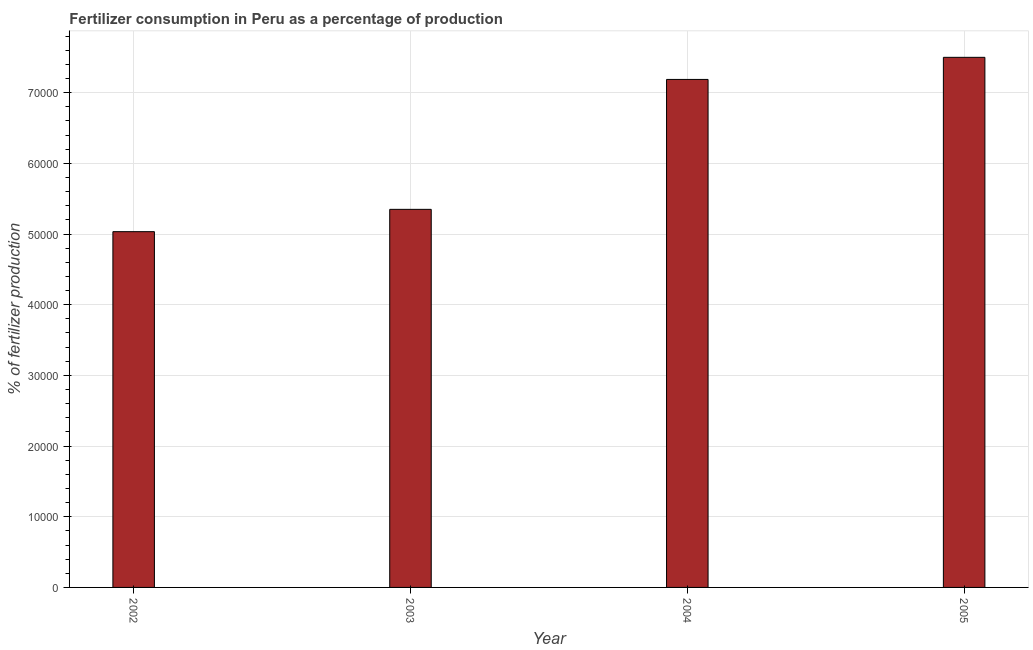Does the graph contain any zero values?
Provide a succinct answer. No. Does the graph contain grids?
Provide a short and direct response. Yes. What is the title of the graph?
Offer a very short reply. Fertilizer consumption in Peru as a percentage of production. What is the label or title of the X-axis?
Keep it short and to the point. Year. What is the label or title of the Y-axis?
Keep it short and to the point. % of fertilizer production. What is the amount of fertilizer consumption in 2005?
Give a very brief answer. 7.50e+04. Across all years, what is the maximum amount of fertilizer consumption?
Offer a very short reply. 7.50e+04. Across all years, what is the minimum amount of fertilizer consumption?
Provide a succinct answer. 5.03e+04. What is the sum of the amount of fertilizer consumption?
Keep it short and to the point. 2.51e+05. What is the difference between the amount of fertilizer consumption in 2003 and 2005?
Provide a short and direct response. -2.15e+04. What is the average amount of fertilizer consumption per year?
Provide a succinct answer. 6.27e+04. What is the median amount of fertilizer consumption?
Keep it short and to the point. 6.27e+04. In how many years, is the amount of fertilizer consumption greater than 18000 %?
Ensure brevity in your answer.  4. What is the difference between the highest and the second highest amount of fertilizer consumption?
Your answer should be compact. 3126.98. What is the difference between the highest and the lowest amount of fertilizer consumption?
Your answer should be very brief. 2.47e+04. In how many years, is the amount of fertilizer consumption greater than the average amount of fertilizer consumption taken over all years?
Your answer should be compact. 2. How many bars are there?
Ensure brevity in your answer.  4. Are all the bars in the graph horizontal?
Your response must be concise. No. How many years are there in the graph?
Provide a short and direct response. 4. What is the difference between two consecutive major ticks on the Y-axis?
Offer a very short reply. 10000. What is the % of fertilizer production of 2002?
Your answer should be very brief. 5.03e+04. What is the % of fertilizer production of 2003?
Make the answer very short. 5.35e+04. What is the % of fertilizer production in 2004?
Your response must be concise. 7.19e+04. What is the % of fertilizer production in 2005?
Offer a very short reply. 7.50e+04. What is the difference between the % of fertilizer production in 2002 and 2003?
Provide a succinct answer. -3157.12. What is the difference between the % of fertilizer production in 2002 and 2004?
Keep it short and to the point. -2.15e+04. What is the difference between the % of fertilizer production in 2002 and 2005?
Provide a short and direct response. -2.47e+04. What is the difference between the % of fertilizer production in 2003 and 2004?
Provide a succinct answer. -1.84e+04. What is the difference between the % of fertilizer production in 2003 and 2005?
Your answer should be very brief. -2.15e+04. What is the difference between the % of fertilizer production in 2004 and 2005?
Provide a short and direct response. -3126.98. What is the ratio of the % of fertilizer production in 2002 to that in 2003?
Provide a succinct answer. 0.94. What is the ratio of the % of fertilizer production in 2002 to that in 2004?
Your answer should be compact. 0.7. What is the ratio of the % of fertilizer production in 2002 to that in 2005?
Offer a very short reply. 0.67. What is the ratio of the % of fertilizer production in 2003 to that in 2004?
Provide a short and direct response. 0.74. What is the ratio of the % of fertilizer production in 2003 to that in 2005?
Keep it short and to the point. 0.71. What is the ratio of the % of fertilizer production in 2004 to that in 2005?
Your response must be concise. 0.96. 